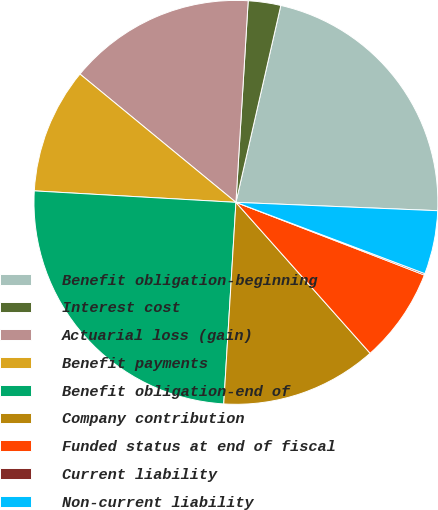Convert chart to OTSL. <chart><loc_0><loc_0><loc_500><loc_500><pie_chart><fcel>Benefit obligation-beginning<fcel>Interest cost<fcel>Actuarial loss (gain)<fcel>Benefit payments<fcel>Benefit obligation-end of<fcel>Company contribution<fcel>Funded status at end of fiscal<fcel>Current liability<fcel>Non-current liability<nl><fcel>22.09%<fcel>2.6%<fcel>15.01%<fcel>10.05%<fcel>24.94%<fcel>12.53%<fcel>7.57%<fcel>0.12%<fcel>5.08%<nl></chart> 